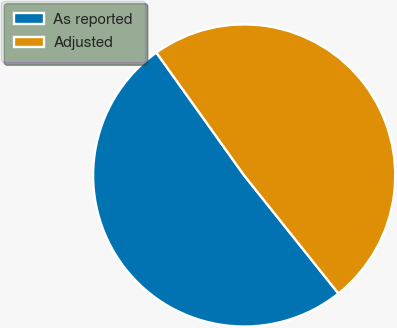<chart> <loc_0><loc_0><loc_500><loc_500><pie_chart><fcel>As reported<fcel>Adjusted<nl><fcel>50.85%<fcel>49.15%<nl></chart> 